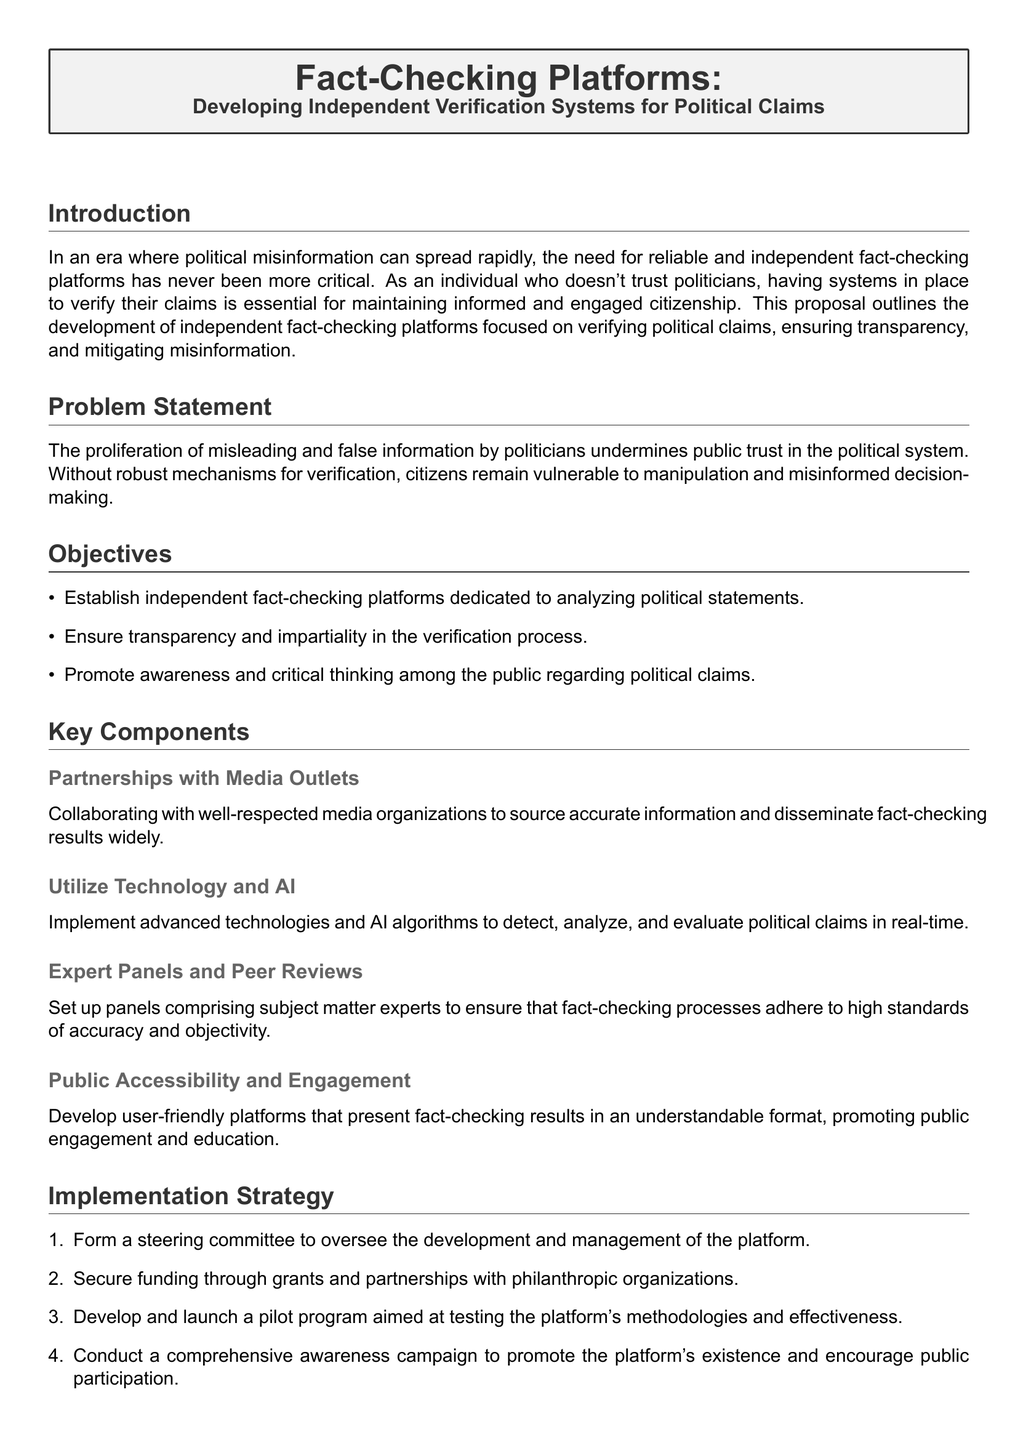What is the main focus of the proposal? The main focus of the proposal is the development of independent verification systems for political claims.
Answer: independent verification systems for political claims What are the three main objectives outlined? The document lists three main objectives: establishing independent platforms, ensuring transparency, and promoting public awareness.
Answer: independent platforms, transparency, public awareness How many key components are listed in the proposal? The proposal enumerates four key components necessary for establishing the fact-checking platform.
Answer: four What is the role of the steering committee? The steering committee's role is to oversee the development and management of the fact-checking platform.
Answer: oversee the development and management What percentage of the document discusses expected outcomes? The section discussing expected outcomes makes up one part of the five-section document, indicating a significant focus on that topic.
Answer: one part How will technology be utilized according to the document? Technology will be utilized to detect, analyze, and evaluate political claims in real-time.
Answer: detect, analyze, evaluate What is one expected outcome of the implementation strategy? One expected outcome is enhanced public trust in verified information.
Answer: enhanced public trust Which type of organizations will provide funding? Funding will be secured through grants and partnerships with philanthropic organizations.
Answer: philanthropic organizations What is the target audience for the public engagement strategy? The target audience for the public engagement strategy is the general public.
Answer: the general public 